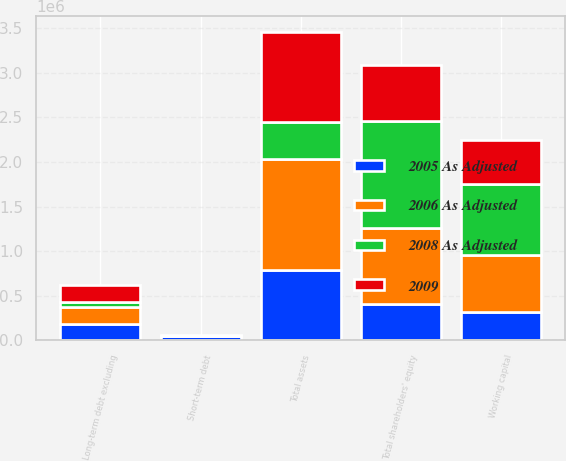<chart> <loc_0><loc_0><loc_500><loc_500><stacked_bar_chart><ecel><fcel>Working capital<fcel>Total assets<fcel>Short-term debt<fcel>Long-term debt excluding<fcel>Total shareholders' equity<nl><fcel>2008 As Adjusted<fcel>793142<fcel>410352<fcel>19<fcel>58022<fcel>1.20375e+06<nl><fcel>2006 As Adjusted<fcel>640227<fcel>1.24108e+06<fcel>21<fcel>182825<fcel>844725<nl><fcel>2009<fcel>494606<fcel>1.01916e+06<fcel>19007<fcel>194270<fcel>631736<nl><fcel>2005 As Adjusted<fcel>316097<fcel>791053<fcel>45507<fcel>188326<fcel>410352<nl></chart> 